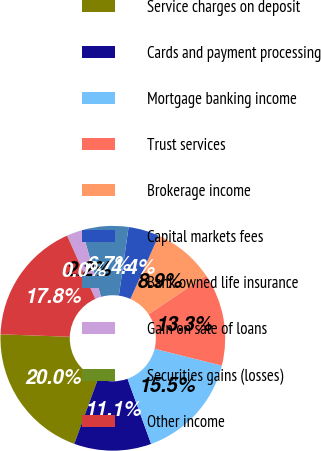Convert chart to OTSL. <chart><loc_0><loc_0><loc_500><loc_500><pie_chart><fcel>Service charges on deposit<fcel>Cards and payment processing<fcel>Mortgage banking income<fcel>Trust services<fcel>Brokerage income<fcel>Capital markets fees<fcel>Bank owned life insurance<fcel>Gain on sale of loans<fcel>Securities gains (losses)<fcel>Other income<nl><fcel>19.99%<fcel>11.11%<fcel>15.55%<fcel>13.33%<fcel>8.89%<fcel>4.45%<fcel>6.67%<fcel>2.23%<fcel>0.01%<fcel>17.77%<nl></chart> 